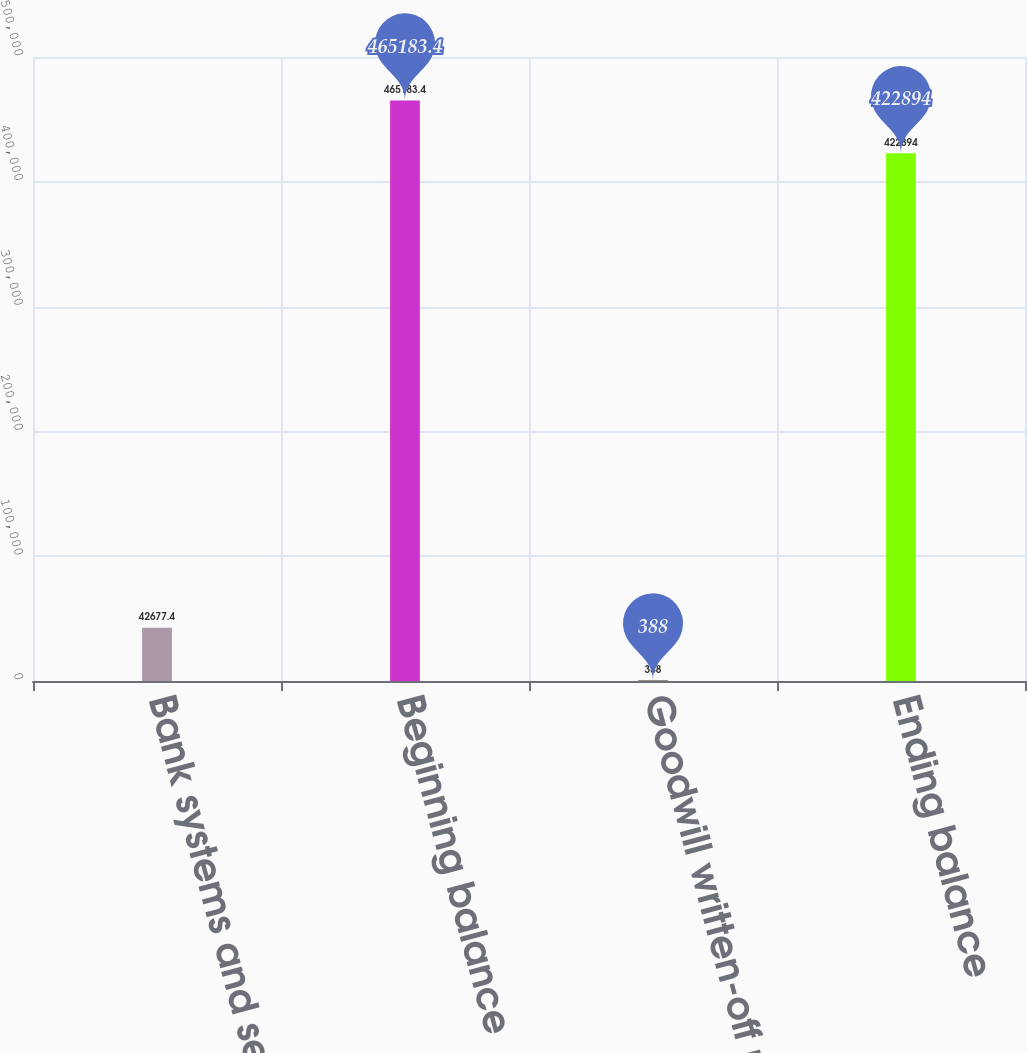Convert chart to OTSL. <chart><loc_0><loc_0><loc_500><loc_500><bar_chart><fcel>Bank systems and services<fcel>Beginning balance<fcel>Goodwill written-off related<fcel>Ending balance<nl><fcel>42677.4<fcel>465183<fcel>388<fcel>422894<nl></chart> 